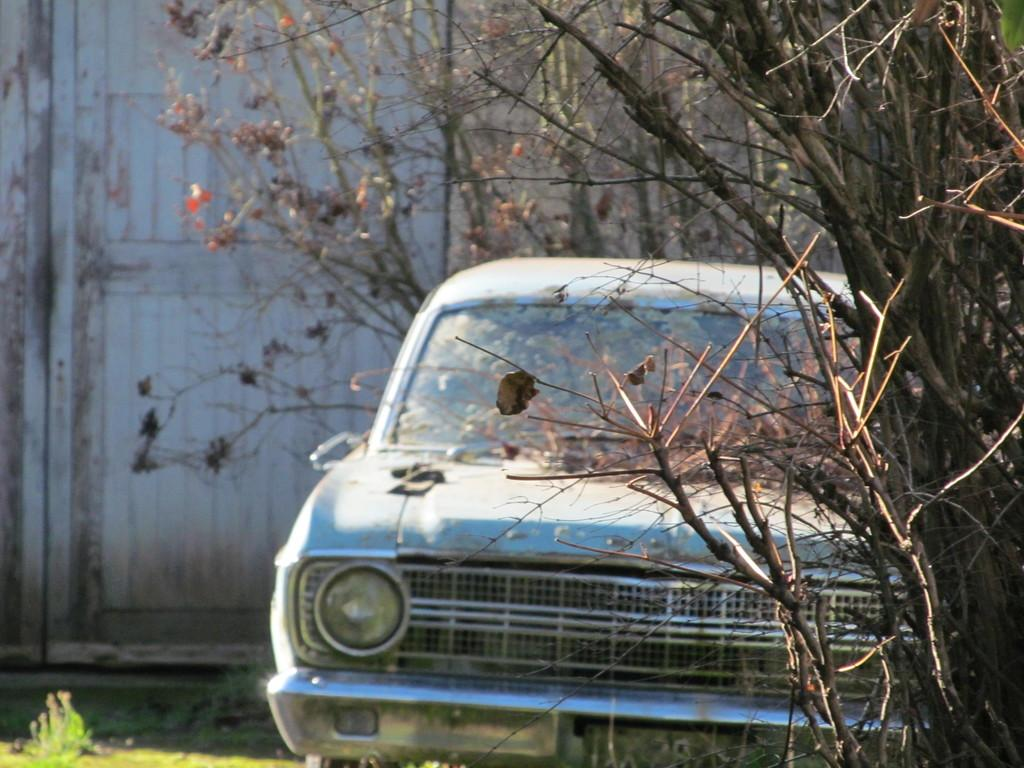What is the main subject of the image? The main subject of the image is a car. What can be seen beside the car in the image? There are trees beside the car in the image. What is visible in the background of the image? There is a wall visible in the background of the image. What type of story is being told by the wax figures in the image? There are no wax figures present in the image; it features a car with trees beside it and a wall in the background. 